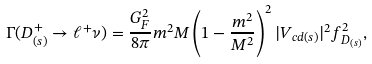Convert formula to latex. <formula><loc_0><loc_0><loc_500><loc_500>\Gamma ( D ^ { + } _ { ( s ) } \to \ell ^ { + } \nu ) = \frac { G ^ { 2 } _ { F } } { 8 \pi } m ^ { 2 } M \left ( 1 - \frac { m ^ { 2 } } { M ^ { 2 } } \right ) ^ { 2 } | V _ { c d ( s ) } | ^ { 2 } f _ { D _ { ( s ) } } ^ { 2 } ,</formula> 